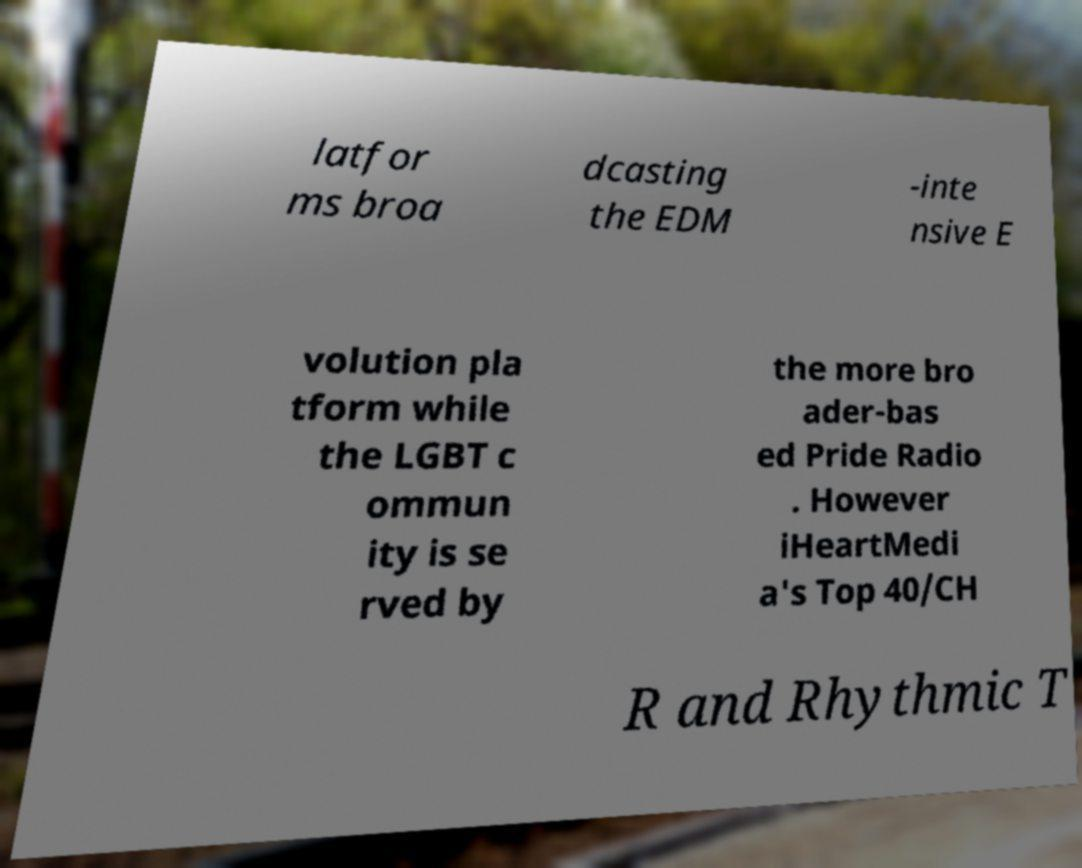Could you extract and type out the text from this image? latfor ms broa dcasting the EDM -inte nsive E volution pla tform while the LGBT c ommun ity is se rved by the more bro ader-bas ed Pride Radio . However iHeartMedi a's Top 40/CH R and Rhythmic T 